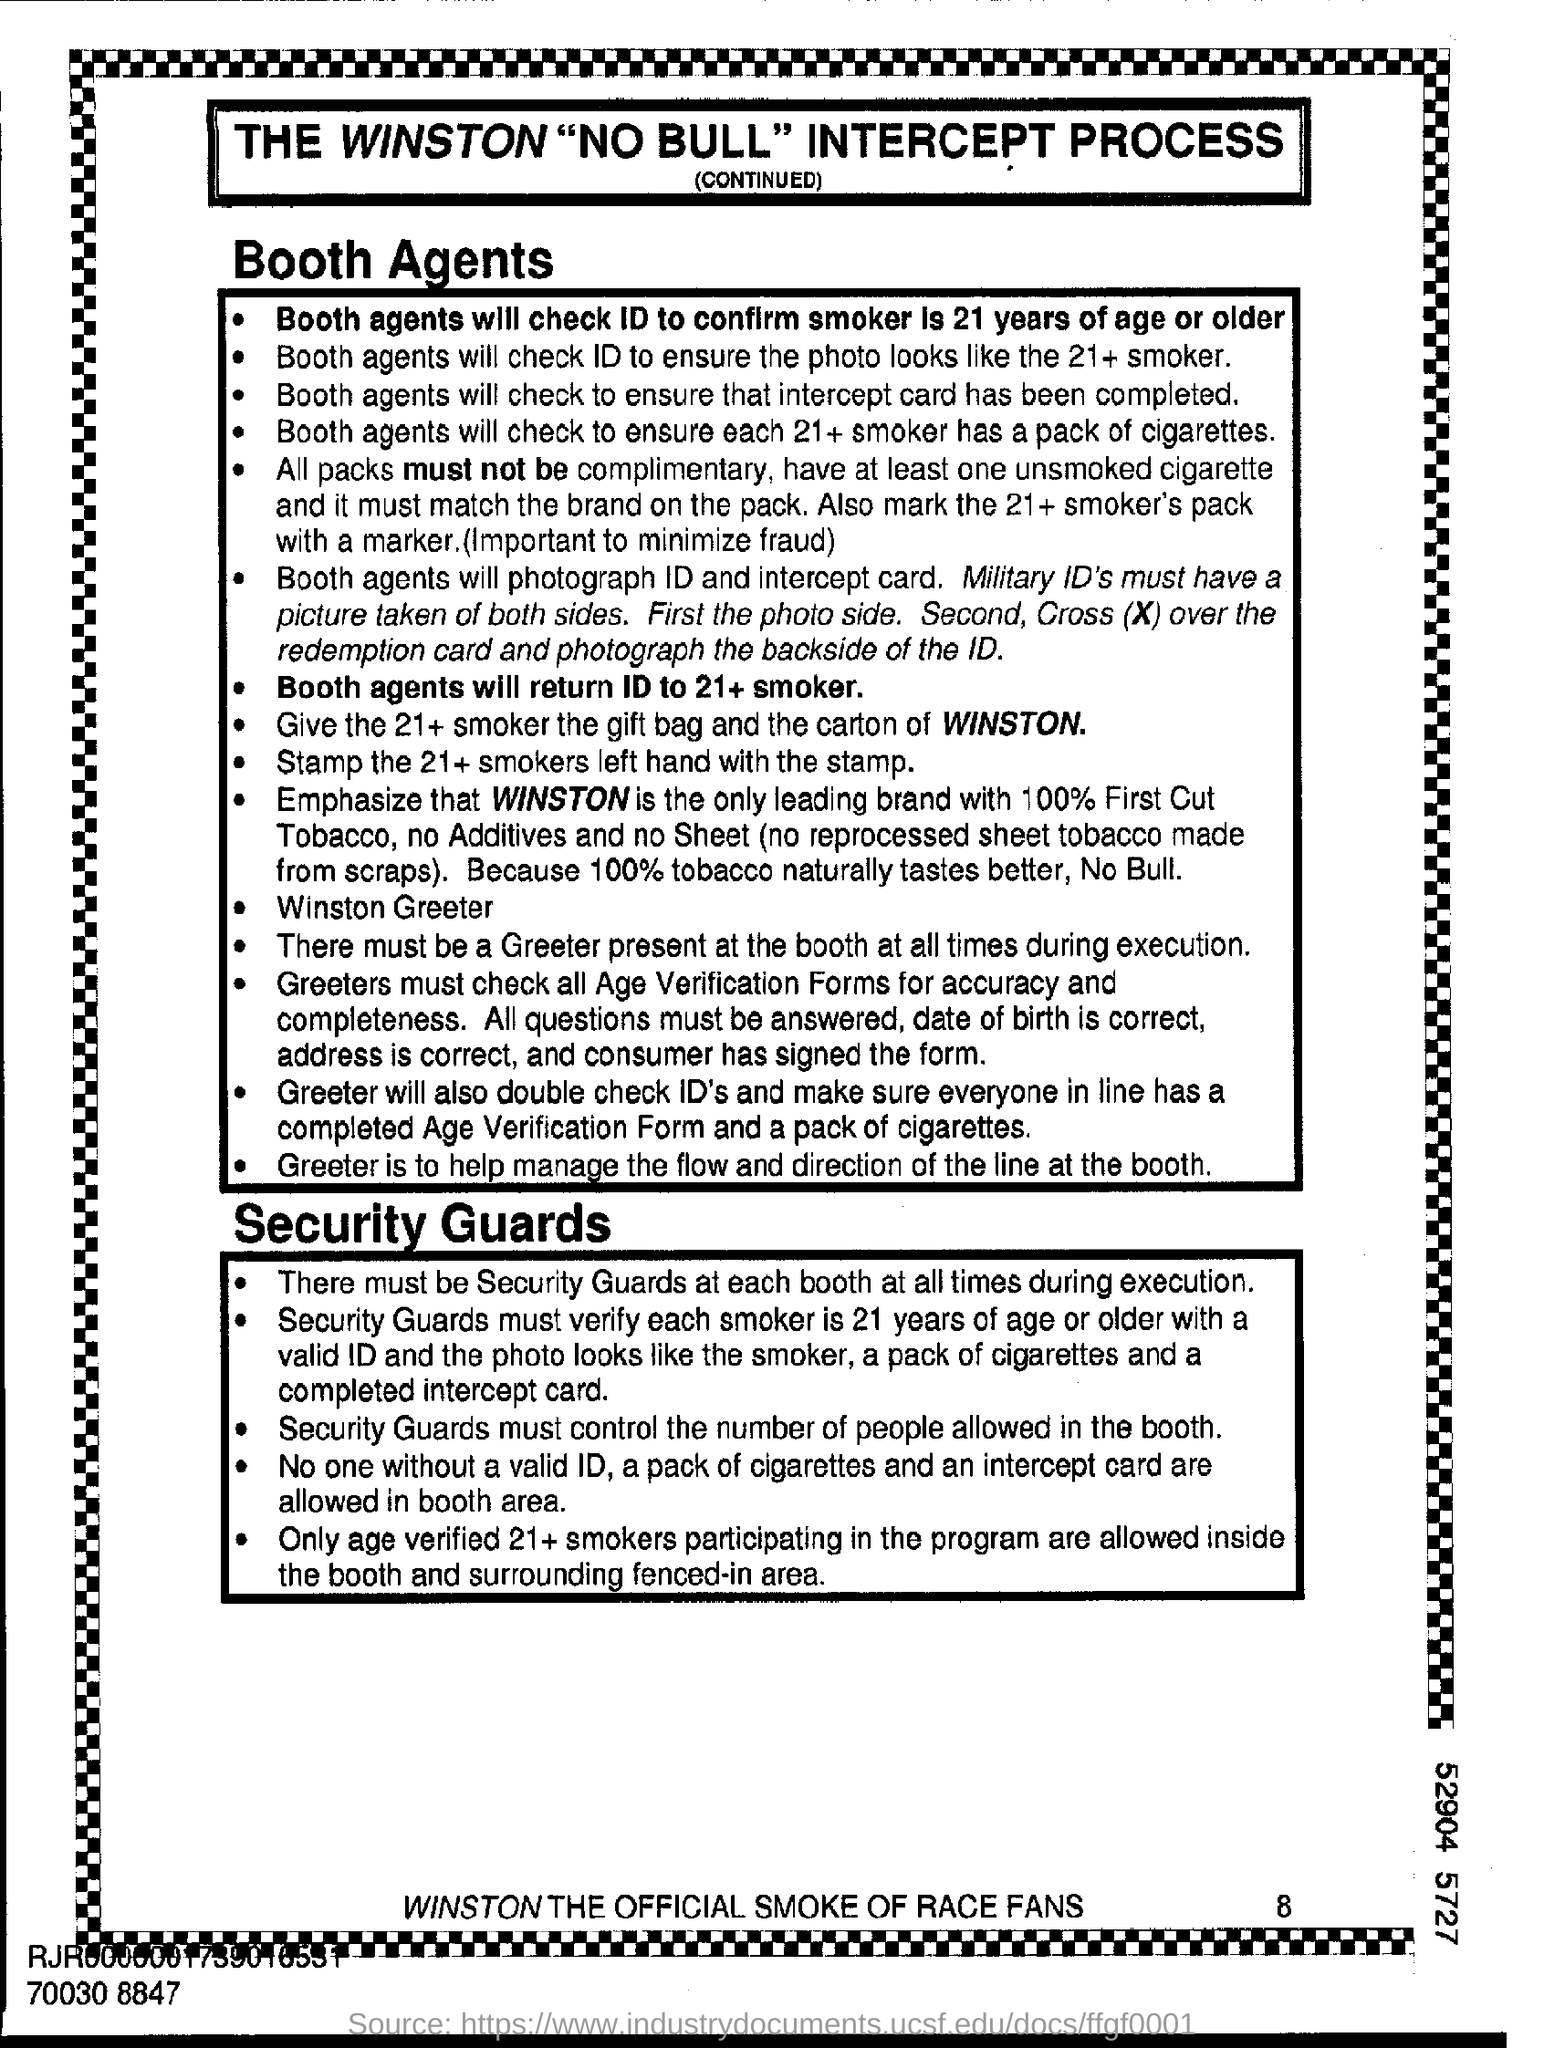Give some essential details in this illustration. Winston is the official smoke of race fans. Military IDs must have a photograph taken of both sides. The smoker should be at least 21 years of age. The process mentioned in the flyer is the Winston "NO BULL" intercept process. It is recommended that the left hand of 21+ smokers be stamped with the stamp. 